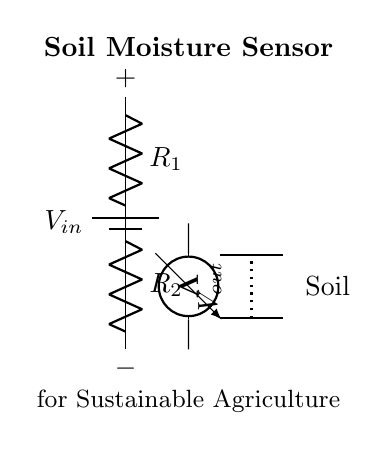What is the power supply voltage in this circuit? The power supply voltage is indicated as \( V_{in} \) in the diagram, which is represented as a battery connected at the top of the circuit.
Answer: \( V_{in} \) What are the resistor labels in the circuit? The resistors in the voltage divider are labeled as \( R_1 \) and \( R_2 \), which can be seen in the circuit diagram next to the respective resistor symbols.
Answer: \( R_1 \) and \( R_2 \) What could be the purpose of the voltmeter in this circuit? The voltmeter is measuring the output voltage \( V_{out} \), which indicates the voltage across the soil moisture sensor connected to the soil probes; this measurement is critical for determining moisture levels.
Answer: Measuring soil moisture How does the configuration of this circuit support soil moisture measurement? The voltage divider configuration allows the output voltage \( V_{out} \) to vary based on the resistance from the soil, resulting in a voltage level that corresponds to the moisture content; thus, the sensor can provide meaningful readings based on this voltage.
Answer: It enables voltage variation with moisture levels What is represented by the dotted line in the circuit? The dotted line indicates the connection between the two soil probes; it visually represents that the voltage reading across \( V_{out} \) is influenced by the soil's resistance across those probes.
Answer: Soil probes connection 